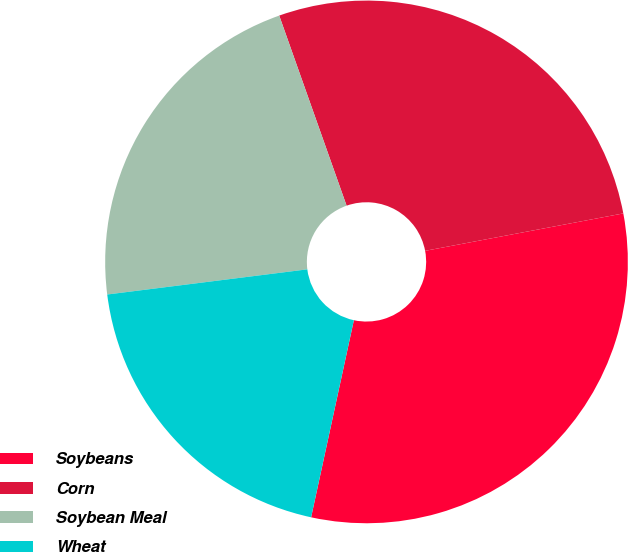Convert chart to OTSL. <chart><loc_0><loc_0><loc_500><loc_500><pie_chart><fcel>Soybeans<fcel>Corn<fcel>Soybean Meal<fcel>Wheat<nl><fcel>31.37%<fcel>27.45%<fcel>21.57%<fcel>19.61%<nl></chart> 